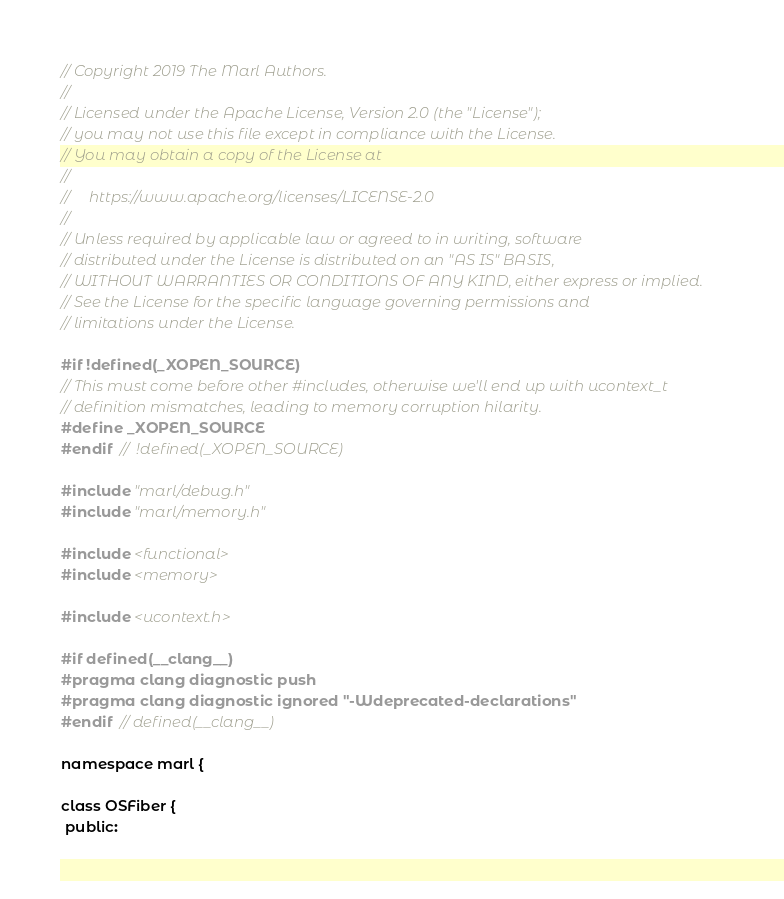Convert code to text. <code><loc_0><loc_0><loc_500><loc_500><_C_>// Copyright 2019 The Marl Authors.
//
// Licensed under the Apache License, Version 2.0 (the "License");
// you may not use this file except in compliance with the License.
// You may obtain a copy of the License at
//
//     https://www.apache.org/licenses/LICENSE-2.0
//
// Unless required by applicable law or agreed to in writing, software
// distributed under the License is distributed on an "AS IS" BASIS,
// WITHOUT WARRANTIES OR CONDITIONS OF ANY KIND, either express or implied.
// See the License for the specific language governing permissions and
// limitations under the License.

#if !defined(_XOPEN_SOURCE)
// This must come before other #includes, otherwise we'll end up with ucontext_t
// definition mismatches, leading to memory corruption hilarity.
#define _XOPEN_SOURCE
#endif  //  !defined(_XOPEN_SOURCE)

#include "marl/debug.h"
#include "marl/memory.h"

#include <functional>
#include <memory>

#include <ucontext.h>

#if defined(__clang__)
#pragma clang diagnostic push
#pragma clang diagnostic ignored "-Wdeprecated-declarations"
#endif  // defined(__clang__)

namespace marl {

class OSFiber {
 public:</code> 